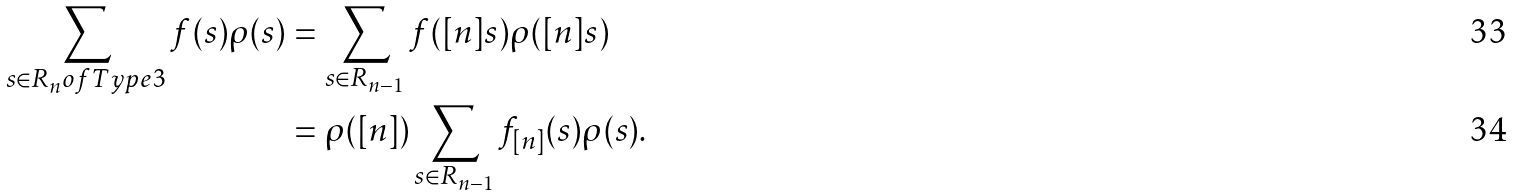<formula> <loc_0><loc_0><loc_500><loc_500>\sum _ { s \in R _ { n } o f T y p e 3 } f ( s ) \rho ( s ) & = \sum _ { s \in R _ { n - 1 } } f ( [ n ] s ) \rho ( [ n ] s ) \\ & = \rho ( [ n ] ) \sum _ { s \in R _ { n - 1 } } f _ { [ n ] } ( s ) \rho ( s ) .</formula> 